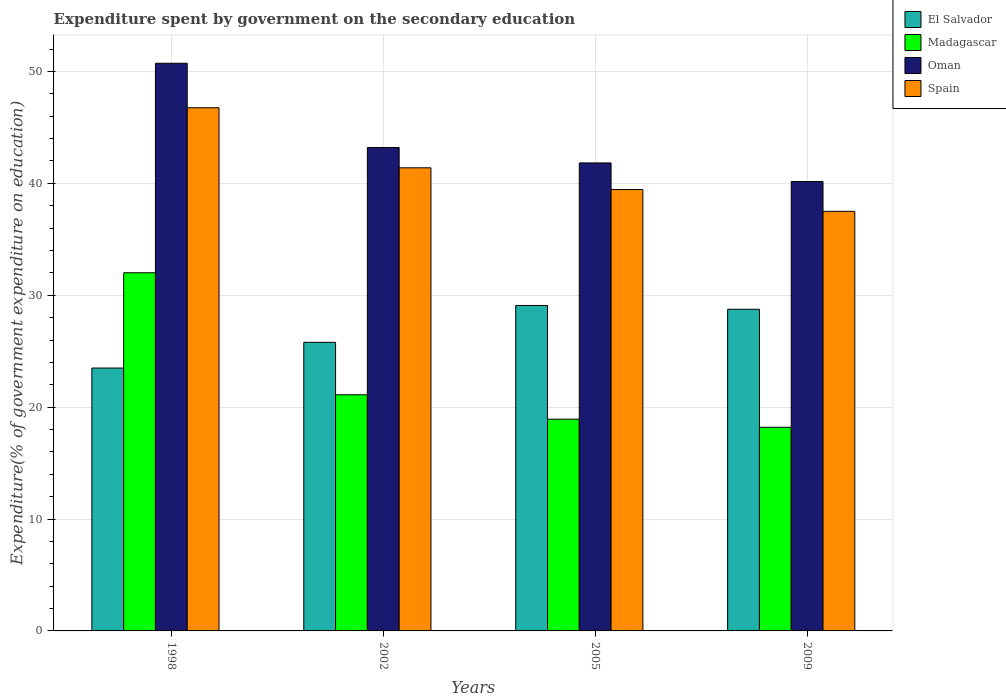How many different coloured bars are there?
Offer a terse response. 4. Are the number of bars per tick equal to the number of legend labels?
Ensure brevity in your answer.  Yes. Are the number of bars on each tick of the X-axis equal?
Offer a very short reply. Yes. What is the label of the 4th group of bars from the left?
Your answer should be compact. 2009. In how many cases, is the number of bars for a given year not equal to the number of legend labels?
Provide a short and direct response. 0. What is the expenditure spent by government on the secondary education in Madagascar in 2005?
Your answer should be very brief. 18.92. Across all years, what is the maximum expenditure spent by government on the secondary education in Madagascar?
Offer a very short reply. 32.01. Across all years, what is the minimum expenditure spent by government on the secondary education in Madagascar?
Your response must be concise. 18.2. What is the total expenditure spent by government on the secondary education in Spain in the graph?
Ensure brevity in your answer.  165.1. What is the difference between the expenditure spent by government on the secondary education in Spain in 2005 and that in 2009?
Keep it short and to the point. 1.95. What is the difference between the expenditure spent by government on the secondary education in Spain in 1998 and the expenditure spent by government on the secondary education in El Salvador in 2009?
Provide a succinct answer. 18.01. What is the average expenditure spent by government on the secondary education in El Salvador per year?
Your answer should be very brief. 26.78. In the year 2009, what is the difference between the expenditure spent by government on the secondary education in Spain and expenditure spent by government on the secondary education in Oman?
Your answer should be compact. -2.66. In how many years, is the expenditure spent by government on the secondary education in Spain greater than 20 %?
Offer a very short reply. 4. What is the ratio of the expenditure spent by government on the secondary education in Oman in 2002 to that in 2009?
Ensure brevity in your answer.  1.08. Is the expenditure spent by government on the secondary education in Madagascar in 1998 less than that in 2005?
Provide a short and direct response. No. Is the difference between the expenditure spent by government on the secondary education in Spain in 2005 and 2009 greater than the difference between the expenditure spent by government on the secondary education in Oman in 2005 and 2009?
Make the answer very short. Yes. What is the difference between the highest and the second highest expenditure spent by government on the secondary education in Spain?
Provide a short and direct response. 5.36. What is the difference between the highest and the lowest expenditure spent by government on the secondary education in Madagascar?
Make the answer very short. 13.81. Is the sum of the expenditure spent by government on the secondary education in El Salvador in 2005 and 2009 greater than the maximum expenditure spent by government on the secondary education in Spain across all years?
Offer a terse response. Yes. What does the 3rd bar from the left in 2009 represents?
Your response must be concise. Oman. What does the 3rd bar from the right in 2005 represents?
Provide a short and direct response. Madagascar. Is it the case that in every year, the sum of the expenditure spent by government on the secondary education in Madagascar and expenditure spent by government on the secondary education in Oman is greater than the expenditure spent by government on the secondary education in Spain?
Provide a short and direct response. Yes. How many bars are there?
Make the answer very short. 16. Are all the bars in the graph horizontal?
Keep it short and to the point. No. How many years are there in the graph?
Give a very brief answer. 4. Are the values on the major ticks of Y-axis written in scientific E-notation?
Your answer should be compact. No. Does the graph contain grids?
Your answer should be compact. Yes. What is the title of the graph?
Keep it short and to the point. Expenditure spent by government on the secondary education. Does "Equatorial Guinea" appear as one of the legend labels in the graph?
Offer a very short reply. No. What is the label or title of the Y-axis?
Make the answer very short. Expenditure(% of government expenditure on education). What is the Expenditure(% of government expenditure on education) of El Salvador in 1998?
Keep it short and to the point. 23.49. What is the Expenditure(% of government expenditure on education) of Madagascar in 1998?
Offer a terse response. 32.01. What is the Expenditure(% of government expenditure on education) of Oman in 1998?
Your response must be concise. 50.73. What is the Expenditure(% of government expenditure on education) in Spain in 1998?
Provide a short and direct response. 46.76. What is the Expenditure(% of government expenditure on education) in El Salvador in 2002?
Make the answer very short. 25.79. What is the Expenditure(% of government expenditure on education) in Madagascar in 2002?
Make the answer very short. 21.11. What is the Expenditure(% of government expenditure on education) in Oman in 2002?
Give a very brief answer. 43.21. What is the Expenditure(% of government expenditure on education) in Spain in 2002?
Provide a short and direct response. 41.39. What is the Expenditure(% of government expenditure on education) of El Salvador in 2005?
Your response must be concise. 29.09. What is the Expenditure(% of government expenditure on education) of Madagascar in 2005?
Offer a very short reply. 18.92. What is the Expenditure(% of government expenditure on education) in Oman in 2005?
Your response must be concise. 41.83. What is the Expenditure(% of government expenditure on education) of Spain in 2005?
Offer a terse response. 39.45. What is the Expenditure(% of government expenditure on education) in El Salvador in 2009?
Your response must be concise. 28.75. What is the Expenditure(% of government expenditure on education) of Madagascar in 2009?
Your answer should be very brief. 18.2. What is the Expenditure(% of government expenditure on education) in Oman in 2009?
Offer a terse response. 40.16. What is the Expenditure(% of government expenditure on education) of Spain in 2009?
Give a very brief answer. 37.5. Across all years, what is the maximum Expenditure(% of government expenditure on education) in El Salvador?
Your answer should be compact. 29.09. Across all years, what is the maximum Expenditure(% of government expenditure on education) in Madagascar?
Give a very brief answer. 32.01. Across all years, what is the maximum Expenditure(% of government expenditure on education) of Oman?
Make the answer very short. 50.73. Across all years, what is the maximum Expenditure(% of government expenditure on education) in Spain?
Give a very brief answer. 46.76. Across all years, what is the minimum Expenditure(% of government expenditure on education) of El Salvador?
Make the answer very short. 23.49. Across all years, what is the minimum Expenditure(% of government expenditure on education) in Madagascar?
Your response must be concise. 18.2. Across all years, what is the minimum Expenditure(% of government expenditure on education) in Oman?
Provide a short and direct response. 40.16. Across all years, what is the minimum Expenditure(% of government expenditure on education) of Spain?
Offer a terse response. 37.5. What is the total Expenditure(% of government expenditure on education) of El Salvador in the graph?
Make the answer very short. 107.12. What is the total Expenditure(% of government expenditure on education) in Madagascar in the graph?
Provide a succinct answer. 90.24. What is the total Expenditure(% of government expenditure on education) in Oman in the graph?
Offer a terse response. 175.93. What is the total Expenditure(% of government expenditure on education) of Spain in the graph?
Provide a short and direct response. 165.1. What is the difference between the Expenditure(% of government expenditure on education) of El Salvador in 1998 and that in 2002?
Your answer should be compact. -2.3. What is the difference between the Expenditure(% of government expenditure on education) of Madagascar in 1998 and that in 2002?
Offer a terse response. 10.91. What is the difference between the Expenditure(% of government expenditure on education) of Oman in 1998 and that in 2002?
Give a very brief answer. 7.53. What is the difference between the Expenditure(% of government expenditure on education) in Spain in 1998 and that in 2002?
Offer a terse response. 5.36. What is the difference between the Expenditure(% of government expenditure on education) in El Salvador in 1998 and that in 2005?
Make the answer very short. -5.6. What is the difference between the Expenditure(% of government expenditure on education) in Madagascar in 1998 and that in 2005?
Your answer should be very brief. 13.09. What is the difference between the Expenditure(% of government expenditure on education) in Oman in 1998 and that in 2005?
Your answer should be very brief. 8.91. What is the difference between the Expenditure(% of government expenditure on education) in Spain in 1998 and that in 2005?
Give a very brief answer. 7.31. What is the difference between the Expenditure(% of government expenditure on education) in El Salvador in 1998 and that in 2009?
Your answer should be very brief. -5.25. What is the difference between the Expenditure(% of government expenditure on education) of Madagascar in 1998 and that in 2009?
Your answer should be compact. 13.81. What is the difference between the Expenditure(% of government expenditure on education) in Oman in 1998 and that in 2009?
Offer a terse response. 10.57. What is the difference between the Expenditure(% of government expenditure on education) of Spain in 1998 and that in 2009?
Your answer should be very brief. 9.26. What is the difference between the Expenditure(% of government expenditure on education) of El Salvador in 2002 and that in 2005?
Ensure brevity in your answer.  -3.29. What is the difference between the Expenditure(% of government expenditure on education) in Madagascar in 2002 and that in 2005?
Make the answer very short. 2.18. What is the difference between the Expenditure(% of government expenditure on education) of Oman in 2002 and that in 2005?
Make the answer very short. 1.38. What is the difference between the Expenditure(% of government expenditure on education) of Spain in 2002 and that in 2005?
Your answer should be very brief. 1.94. What is the difference between the Expenditure(% of government expenditure on education) in El Salvador in 2002 and that in 2009?
Your answer should be compact. -2.95. What is the difference between the Expenditure(% of government expenditure on education) of Madagascar in 2002 and that in 2009?
Give a very brief answer. 2.9. What is the difference between the Expenditure(% of government expenditure on education) in Oman in 2002 and that in 2009?
Ensure brevity in your answer.  3.04. What is the difference between the Expenditure(% of government expenditure on education) in Spain in 2002 and that in 2009?
Provide a short and direct response. 3.89. What is the difference between the Expenditure(% of government expenditure on education) of El Salvador in 2005 and that in 2009?
Provide a short and direct response. 0.34. What is the difference between the Expenditure(% of government expenditure on education) of Madagascar in 2005 and that in 2009?
Your answer should be compact. 0.72. What is the difference between the Expenditure(% of government expenditure on education) of Oman in 2005 and that in 2009?
Your answer should be compact. 1.66. What is the difference between the Expenditure(% of government expenditure on education) of Spain in 2005 and that in 2009?
Your answer should be compact. 1.95. What is the difference between the Expenditure(% of government expenditure on education) in El Salvador in 1998 and the Expenditure(% of government expenditure on education) in Madagascar in 2002?
Your answer should be compact. 2.39. What is the difference between the Expenditure(% of government expenditure on education) of El Salvador in 1998 and the Expenditure(% of government expenditure on education) of Oman in 2002?
Offer a very short reply. -19.71. What is the difference between the Expenditure(% of government expenditure on education) of El Salvador in 1998 and the Expenditure(% of government expenditure on education) of Spain in 2002?
Provide a short and direct response. -17.9. What is the difference between the Expenditure(% of government expenditure on education) of Madagascar in 1998 and the Expenditure(% of government expenditure on education) of Oman in 2002?
Make the answer very short. -11.19. What is the difference between the Expenditure(% of government expenditure on education) in Madagascar in 1998 and the Expenditure(% of government expenditure on education) in Spain in 2002?
Keep it short and to the point. -9.38. What is the difference between the Expenditure(% of government expenditure on education) in Oman in 1998 and the Expenditure(% of government expenditure on education) in Spain in 2002?
Make the answer very short. 9.34. What is the difference between the Expenditure(% of government expenditure on education) of El Salvador in 1998 and the Expenditure(% of government expenditure on education) of Madagascar in 2005?
Your response must be concise. 4.57. What is the difference between the Expenditure(% of government expenditure on education) in El Salvador in 1998 and the Expenditure(% of government expenditure on education) in Oman in 2005?
Your answer should be very brief. -18.33. What is the difference between the Expenditure(% of government expenditure on education) of El Salvador in 1998 and the Expenditure(% of government expenditure on education) of Spain in 2005?
Offer a very short reply. -15.96. What is the difference between the Expenditure(% of government expenditure on education) in Madagascar in 1998 and the Expenditure(% of government expenditure on education) in Oman in 2005?
Make the answer very short. -9.82. What is the difference between the Expenditure(% of government expenditure on education) in Madagascar in 1998 and the Expenditure(% of government expenditure on education) in Spain in 2005?
Provide a short and direct response. -7.44. What is the difference between the Expenditure(% of government expenditure on education) in Oman in 1998 and the Expenditure(% of government expenditure on education) in Spain in 2005?
Your answer should be very brief. 11.28. What is the difference between the Expenditure(% of government expenditure on education) of El Salvador in 1998 and the Expenditure(% of government expenditure on education) of Madagascar in 2009?
Ensure brevity in your answer.  5.29. What is the difference between the Expenditure(% of government expenditure on education) in El Salvador in 1998 and the Expenditure(% of government expenditure on education) in Oman in 2009?
Provide a short and direct response. -16.67. What is the difference between the Expenditure(% of government expenditure on education) in El Salvador in 1998 and the Expenditure(% of government expenditure on education) in Spain in 2009?
Provide a succinct answer. -14.01. What is the difference between the Expenditure(% of government expenditure on education) in Madagascar in 1998 and the Expenditure(% of government expenditure on education) in Oman in 2009?
Give a very brief answer. -8.15. What is the difference between the Expenditure(% of government expenditure on education) in Madagascar in 1998 and the Expenditure(% of government expenditure on education) in Spain in 2009?
Offer a terse response. -5.49. What is the difference between the Expenditure(% of government expenditure on education) in Oman in 1998 and the Expenditure(% of government expenditure on education) in Spain in 2009?
Your answer should be very brief. 13.23. What is the difference between the Expenditure(% of government expenditure on education) in El Salvador in 2002 and the Expenditure(% of government expenditure on education) in Madagascar in 2005?
Ensure brevity in your answer.  6.87. What is the difference between the Expenditure(% of government expenditure on education) in El Salvador in 2002 and the Expenditure(% of government expenditure on education) in Oman in 2005?
Offer a very short reply. -16.03. What is the difference between the Expenditure(% of government expenditure on education) in El Salvador in 2002 and the Expenditure(% of government expenditure on education) in Spain in 2005?
Your answer should be compact. -13.66. What is the difference between the Expenditure(% of government expenditure on education) in Madagascar in 2002 and the Expenditure(% of government expenditure on education) in Oman in 2005?
Make the answer very short. -20.72. What is the difference between the Expenditure(% of government expenditure on education) in Madagascar in 2002 and the Expenditure(% of government expenditure on education) in Spain in 2005?
Offer a terse response. -18.35. What is the difference between the Expenditure(% of government expenditure on education) of Oman in 2002 and the Expenditure(% of government expenditure on education) of Spain in 2005?
Provide a short and direct response. 3.75. What is the difference between the Expenditure(% of government expenditure on education) of El Salvador in 2002 and the Expenditure(% of government expenditure on education) of Madagascar in 2009?
Your answer should be very brief. 7.59. What is the difference between the Expenditure(% of government expenditure on education) in El Salvador in 2002 and the Expenditure(% of government expenditure on education) in Oman in 2009?
Provide a succinct answer. -14.37. What is the difference between the Expenditure(% of government expenditure on education) of El Salvador in 2002 and the Expenditure(% of government expenditure on education) of Spain in 2009?
Your response must be concise. -11.71. What is the difference between the Expenditure(% of government expenditure on education) of Madagascar in 2002 and the Expenditure(% of government expenditure on education) of Oman in 2009?
Ensure brevity in your answer.  -19.06. What is the difference between the Expenditure(% of government expenditure on education) of Madagascar in 2002 and the Expenditure(% of government expenditure on education) of Spain in 2009?
Provide a succinct answer. -16.4. What is the difference between the Expenditure(% of government expenditure on education) of Oman in 2002 and the Expenditure(% of government expenditure on education) of Spain in 2009?
Offer a terse response. 5.7. What is the difference between the Expenditure(% of government expenditure on education) in El Salvador in 2005 and the Expenditure(% of government expenditure on education) in Madagascar in 2009?
Offer a very short reply. 10.89. What is the difference between the Expenditure(% of government expenditure on education) of El Salvador in 2005 and the Expenditure(% of government expenditure on education) of Oman in 2009?
Give a very brief answer. -11.07. What is the difference between the Expenditure(% of government expenditure on education) in El Salvador in 2005 and the Expenditure(% of government expenditure on education) in Spain in 2009?
Offer a very short reply. -8.41. What is the difference between the Expenditure(% of government expenditure on education) in Madagascar in 2005 and the Expenditure(% of government expenditure on education) in Oman in 2009?
Your answer should be very brief. -21.24. What is the difference between the Expenditure(% of government expenditure on education) of Madagascar in 2005 and the Expenditure(% of government expenditure on education) of Spain in 2009?
Keep it short and to the point. -18.58. What is the difference between the Expenditure(% of government expenditure on education) of Oman in 2005 and the Expenditure(% of government expenditure on education) of Spain in 2009?
Give a very brief answer. 4.33. What is the average Expenditure(% of government expenditure on education) in El Salvador per year?
Your response must be concise. 26.78. What is the average Expenditure(% of government expenditure on education) in Madagascar per year?
Make the answer very short. 22.56. What is the average Expenditure(% of government expenditure on education) in Oman per year?
Provide a succinct answer. 43.98. What is the average Expenditure(% of government expenditure on education) of Spain per year?
Your response must be concise. 41.27. In the year 1998, what is the difference between the Expenditure(% of government expenditure on education) in El Salvador and Expenditure(% of government expenditure on education) in Madagascar?
Offer a very short reply. -8.52. In the year 1998, what is the difference between the Expenditure(% of government expenditure on education) in El Salvador and Expenditure(% of government expenditure on education) in Oman?
Provide a short and direct response. -27.24. In the year 1998, what is the difference between the Expenditure(% of government expenditure on education) in El Salvador and Expenditure(% of government expenditure on education) in Spain?
Your answer should be compact. -23.26. In the year 1998, what is the difference between the Expenditure(% of government expenditure on education) of Madagascar and Expenditure(% of government expenditure on education) of Oman?
Provide a short and direct response. -18.72. In the year 1998, what is the difference between the Expenditure(% of government expenditure on education) in Madagascar and Expenditure(% of government expenditure on education) in Spain?
Provide a short and direct response. -14.75. In the year 1998, what is the difference between the Expenditure(% of government expenditure on education) in Oman and Expenditure(% of government expenditure on education) in Spain?
Offer a very short reply. 3.98. In the year 2002, what is the difference between the Expenditure(% of government expenditure on education) in El Salvador and Expenditure(% of government expenditure on education) in Madagascar?
Keep it short and to the point. 4.69. In the year 2002, what is the difference between the Expenditure(% of government expenditure on education) of El Salvador and Expenditure(% of government expenditure on education) of Oman?
Provide a succinct answer. -17.41. In the year 2002, what is the difference between the Expenditure(% of government expenditure on education) of El Salvador and Expenditure(% of government expenditure on education) of Spain?
Make the answer very short. -15.6. In the year 2002, what is the difference between the Expenditure(% of government expenditure on education) in Madagascar and Expenditure(% of government expenditure on education) in Oman?
Give a very brief answer. -22.1. In the year 2002, what is the difference between the Expenditure(% of government expenditure on education) of Madagascar and Expenditure(% of government expenditure on education) of Spain?
Give a very brief answer. -20.29. In the year 2002, what is the difference between the Expenditure(% of government expenditure on education) of Oman and Expenditure(% of government expenditure on education) of Spain?
Ensure brevity in your answer.  1.81. In the year 2005, what is the difference between the Expenditure(% of government expenditure on education) of El Salvador and Expenditure(% of government expenditure on education) of Madagascar?
Offer a very short reply. 10.16. In the year 2005, what is the difference between the Expenditure(% of government expenditure on education) of El Salvador and Expenditure(% of government expenditure on education) of Oman?
Give a very brief answer. -12.74. In the year 2005, what is the difference between the Expenditure(% of government expenditure on education) in El Salvador and Expenditure(% of government expenditure on education) in Spain?
Provide a short and direct response. -10.36. In the year 2005, what is the difference between the Expenditure(% of government expenditure on education) of Madagascar and Expenditure(% of government expenditure on education) of Oman?
Your answer should be very brief. -22.9. In the year 2005, what is the difference between the Expenditure(% of government expenditure on education) of Madagascar and Expenditure(% of government expenditure on education) of Spain?
Your answer should be very brief. -20.53. In the year 2005, what is the difference between the Expenditure(% of government expenditure on education) of Oman and Expenditure(% of government expenditure on education) of Spain?
Give a very brief answer. 2.38. In the year 2009, what is the difference between the Expenditure(% of government expenditure on education) of El Salvador and Expenditure(% of government expenditure on education) of Madagascar?
Your answer should be compact. 10.55. In the year 2009, what is the difference between the Expenditure(% of government expenditure on education) in El Salvador and Expenditure(% of government expenditure on education) in Oman?
Provide a succinct answer. -11.42. In the year 2009, what is the difference between the Expenditure(% of government expenditure on education) of El Salvador and Expenditure(% of government expenditure on education) of Spain?
Offer a terse response. -8.75. In the year 2009, what is the difference between the Expenditure(% of government expenditure on education) in Madagascar and Expenditure(% of government expenditure on education) in Oman?
Ensure brevity in your answer.  -21.96. In the year 2009, what is the difference between the Expenditure(% of government expenditure on education) of Madagascar and Expenditure(% of government expenditure on education) of Spain?
Your response must be concise. -19.3. In the year 2009, what is the difference between the Expenditure(% of government expenditure on education) of Oman and Expenditure(% of government expenditure on education) of Spain?
Your answer should be very brief. 2.66. What is the ratio of the Expenditure(% of government expenditure on education) in El Salvador in 1998 to that in 2002?
Give a very brief answer. 0.91. What is the ratio of the Expenditure(% of government expenditure on education) in Madagascar in 1998 to that in 2002?
Offer a very short reply. 1.52. What is the ratio of the Expenditure(% of government expenditure on education) of Oman in 1998 to that in 2002?
Your answer should be compact. 1.17. What is the ratio of the Expenditure(% of government expenditure on education) of Spain in 1998 to that in 2002?
Keep it short and to the point. 1.13. What is the ratio of the Expenditure(% of government expenditure on education) of El Salvador in 1998 to that in 2005?
Offer a terse response. 0.81. What is the ratio of the Expenditure(% of government expenditure on education) in Madagascar in 1998 to that in 2005?
Offer a very short reply. 1.69. What is the ratio of the Expenditure(% of government expenditure on education) in Oman in 1998 to that in 2005?
Offer a very short reply. 1.21. What is the ratio of the Expenditure(% of government expenditure on education) in Spain in 1998 to that in 2005?
Offer a terse response. 1.19. What is the ratio of the Expenditure(% of government expenditure on education) in El Salvador in 1998 to that in 2009?
Your response must be concise. 0.82. What is the ratio of the Expenditure(% of government expenditure on education) of Madagascar in 1998 to that in 2009?
Give a very brief answer. 1.76. What is the ratio of the Expenditure(% of government expenditure on education) in Oman in 1998 to that in 2009?
Make the answer very short. 1.26. What is the ratio of the Expenditure(% of government expenditure on education) in Spain in 1998 to that in 2009?
Your response must be concise. 1.25. What is the ratio of the Expenditure(% of government expenditure on education) of El Salvador in 2002 to that in 2005?
Provide a succinct answer. 0.89. What is the ratio of the Expenditure(% of government expenditure on education) of Madagascar in 2002 to that in 2005?
Your answer should be compact. 1.12. What is the ratio of the Expenditure(% of government expenditure on education) in Oman in 2002 to that in 2005?
Your response must be concise. 1.03. What is the ratio of the Expenditure(% of government expenditure on education) of Spain in 2002 to that in 2005?
Ensure brevity in your answer.  1.05. What is the ratio of the Expenditure(% of government expenditure on education) of El Salvador in 2002 to that in 2009?
Your answer should be very brief. 0.9. What is the ratio of the Expenditure(% of government expenditure on education) of Madagascar in 2002 to that in 2009?
Your answer should be compact. 1.16. What is the ratio of the Expenditure(% of government expenditure on education) in Oman in 2002 to that in 2009?
Your answer should be compact. 1.08. What is the ratio of the Expenditure(% of government expenditure on education) in Spain in 2002 to that in 2009?
Provide a short and direct response. 1.1. What is the ratio of the Expenditure(% of government expenditure on education) of El Salvador in 2005 to that in 2009?
Give a very brief answer. 1.01. What is the ratio of the Expenditure(% of government expenditure on education) in Madagascar in 2005 to that in 2009?
Give a very brief answer. 1.04. What is the ratio of the Expenditure(% of government expenditure on education) of Oman in 2005 to that in 2009?
Your answer should be very brief. 1.04. What is the ratio of the Expenditure(% of government expenditure on education) in Spain in 2005 to that in 2009?
Offer a very short reply. 1.05. What is the difference between the highest and the second highest Expenditure(% of government expenditure on education) of El Salvador?
Your answer should be very brief. 0.34. What is the difference between the highest and the second highest Expenditure(% of government expenditure on education) in Madagascar?
Keep it short and to the point. 10.91. What is the difference between the highest and the second highest Expenditure(% of government expenditure on education) of Oman?
Your response must be concise. 7.53. What is the difference between the highest and the second highest Expenditure(% of government expenditure on education) of Spain?
Offer a very short reply. 5.36. What is the difference between the highest and the lowest Expenditure(% of government expenditure on education) of El Salvador?
Your answer should be very brief. 5.6. What is the difference between the highest and the lowest Expenditure(% of government expenditure on education) in Madagascar?
Offer a terse response. 13.81. What is the difference between the highest and the lowest Expenditure(% of government expenditure on education) in Oman?
Offer a very short reply. 10.57. What is the difference between the highest and the lowest Expenditure(% of government expenditure on education) of Spain?
Your response must be concise. 9.26. 